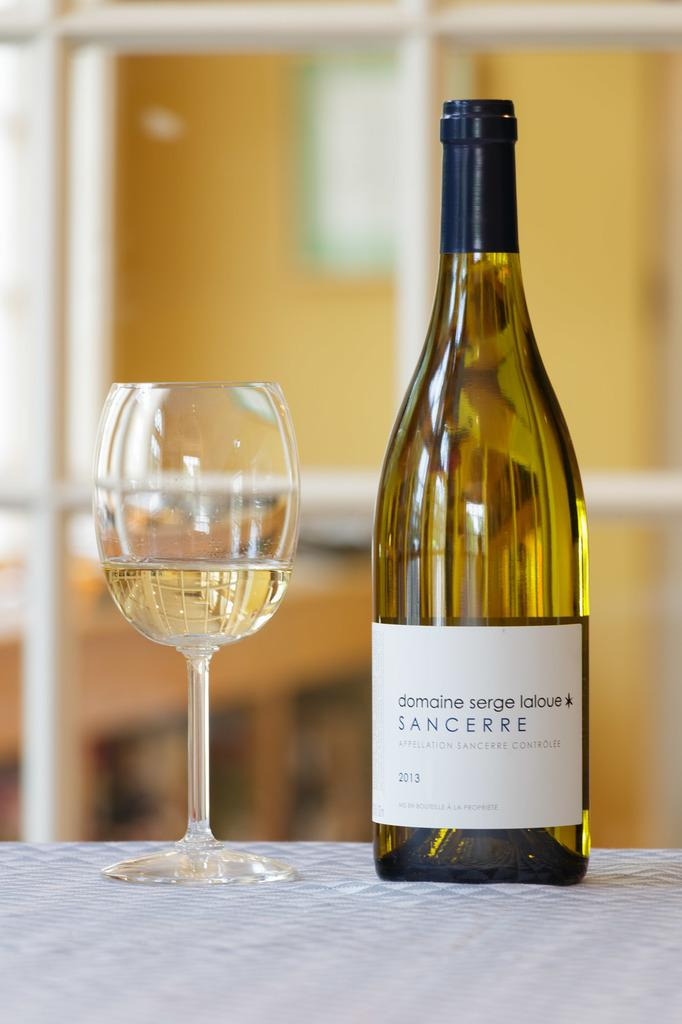What type of beverage container is present in the image? There is a wine bottle in the image. What is the wine bottle accompanied by? There is a glass in the image. Where are the wine bottle and the glass located? Both the wine bottle and the glass are on a table. How many family members are swimming in the image? There is no reference to family members or swimming in the image; it only features a wine bottle and a glass on a table. 